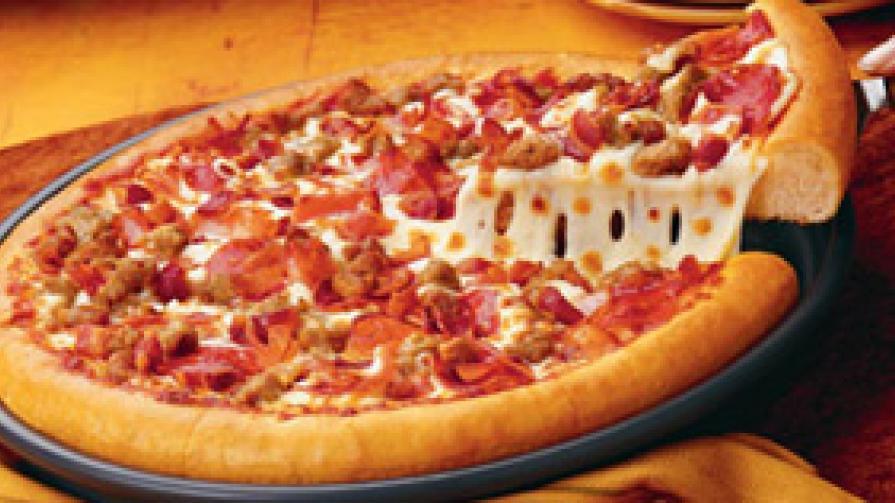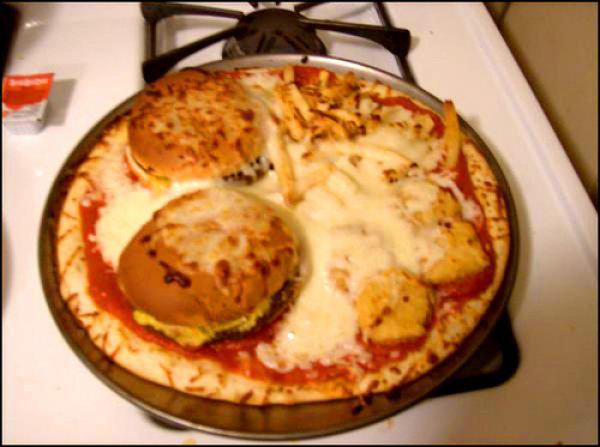The first image is the image on the left, the second image is the image on the right. Evaluate the accuracy of this statement regarding the images: "The pizza in the image to the right has green peppers on it.". Is it true? Answer yes or no. No. The first image is the image on the left, the second image is the image on the right. Analyze the images presented: Is the assertion "The right image shows one complete unsliced pizza with multiple hamburgers on top of it, and the left image shows a pizza with at least one slice not on its round dark pan." valid? Answer yes or no. Yes. 